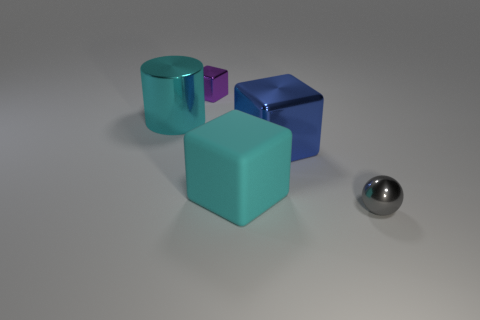Add 4 matte blocks. How many objects exist? 9 Subtract all blocks. How many objects are left? 2 Add 5 purple metal things. How many purple metal things are left? 6 Add 3 purple cubes. How many purple cubes exist? 4 Subtract 0 gray cylinders. How many objects are left? 5 Subtract all cyan cubes. Subtract all large matte objects. How many objects are left? 3 